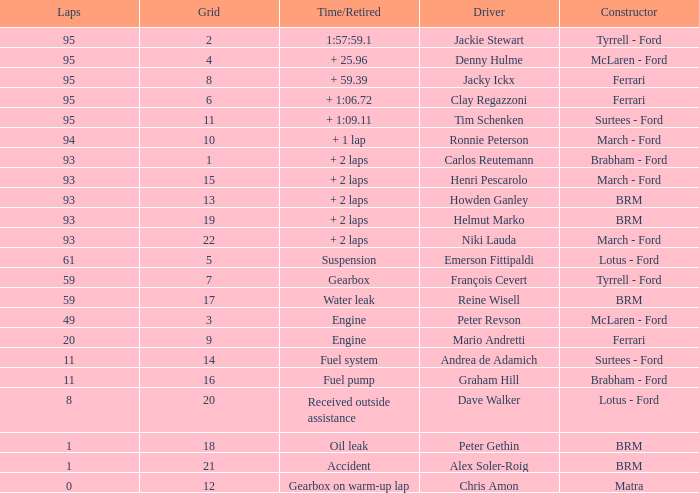How many grids does dave walker have? 1.0. 